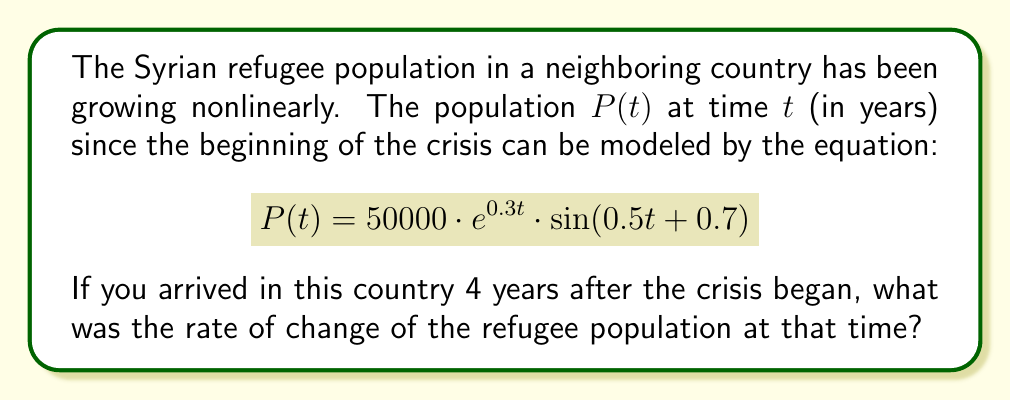Teach me how to tackle this problem. To find the rate of change of the refugee population at t = 4 years, we need to calculate the derivative of P(t) and evaluate it at t = 4.

Step 1: Calculate dP/dt using the product rule.
$$\frac{dP}{dt} = 50000 \cdot \frac{d}{dt}[e^{0.3t} \cdot \sin(0.5t + 0.7)]$$
$$= 50000 \cdot [0.3e^{0.3t} \cdot \sin(0.5t + 0.7) + e^{0.3t} \cdot 0.5\cos(0.5t + 0.7)]$$

Step 2: Simplify the expression.
$$\frac{dP}{dt} = 50000e^{0.3t} \cdot [0.3\sin(0.5t + 0.7) + 0.5\cos(0.5t + 0.7)]$$

Step 3: Evaluate dP/dt at t = 4.
$$\frac{dP}{dt}\bigg|_{t=4} = 50000e^{0.3(4)} \cdot [0.3\sin(0.5(4) + 0.7) + 0.5\cos(0.5(4) + 0.7)]$$
$$= 50000e^{1.2} \cdot [0.3\sin(2.7) + 0.5\cos(2.7)]$$

Step 4: Calculate the numerical value.
$$\frac{dP}{dt}\bigg|_{t=4} \approx 166810.053 \cdot [0.3 \cdot 0.4040 + 0.5 \cdot (-0.9147)]$$
$$\approx 166810.053 \cdot (-0.3352)$$
$$\approx -55,914.7$$
Answer: $-55,915$ refugees/year 